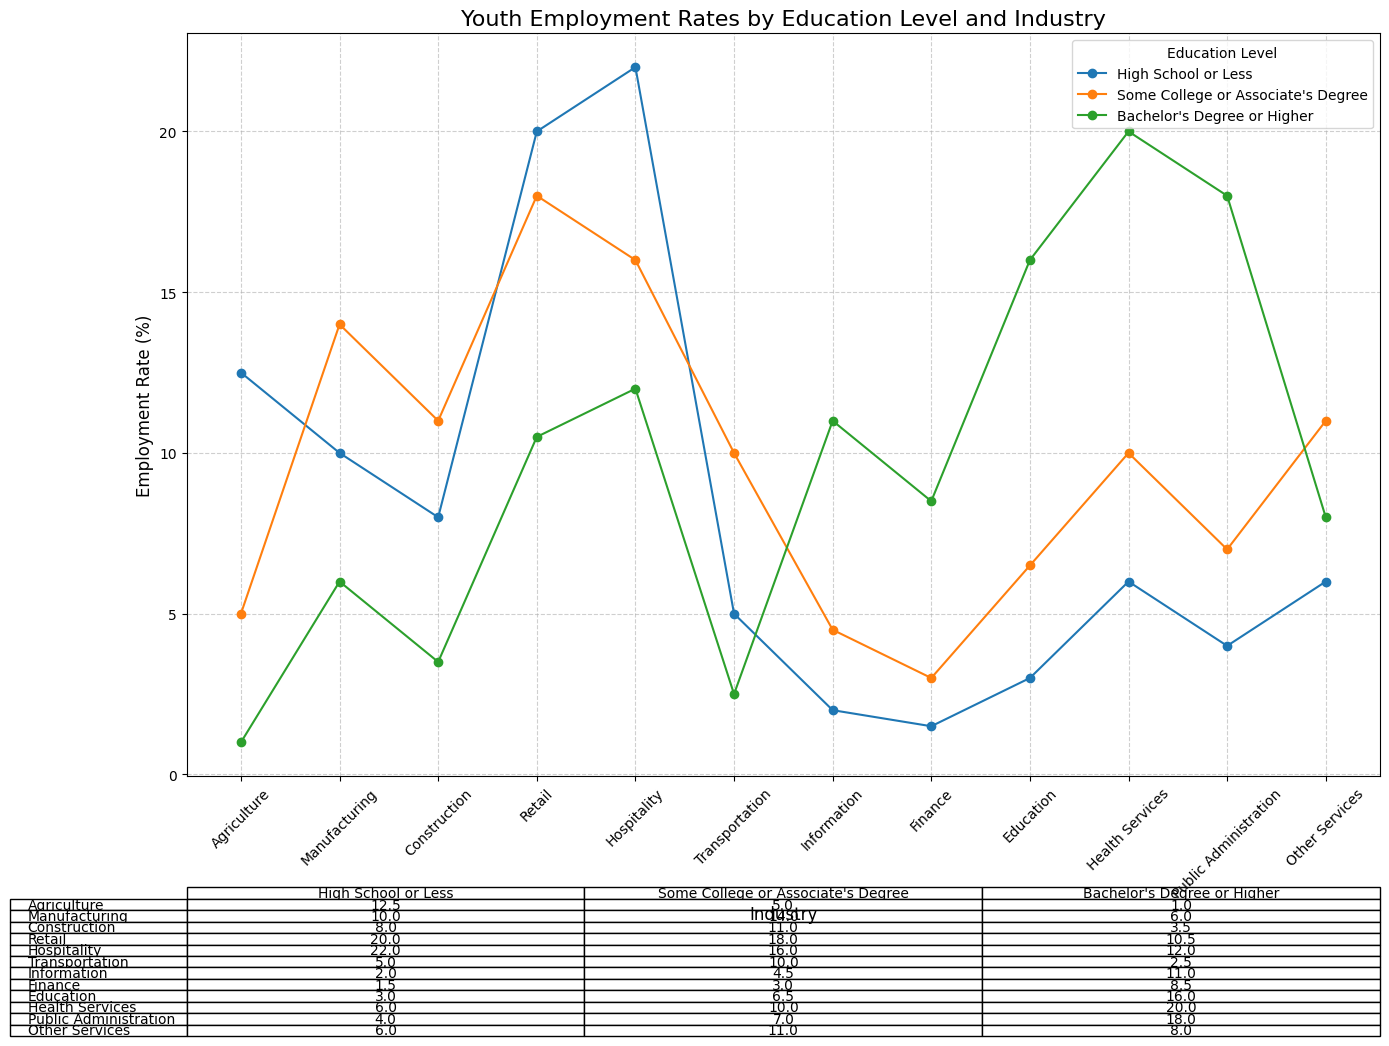Which industry has the highest employment rate for youth with a high school or less education level? Look at the plot and identify the industry with the highest marker for the "High School or Less" education level.
Answer: Hospitality What is the difference in employment rates for youth with some college or an associate's degree between the manufacturing and retail industries? Check the plot for the markers corresponding to "Some College or Associate's Degree" in the manufacturing industry (14.0%) and retail industry (18.0%). Calculate the difference: 18.0% - 14.0% = 4.0%.
Answer: 4.0% Compare the employment rates in the health services industry between youth with a high school or less and a bachelor's degree or higher education level. Which is higher? Look at the plot to find the employment rates in the health services industry for "High School or Less" (6.0%) and "Bachelor's Degree or Higher" (20.0%). The latter is higher.
Answer: Bachelor's Degree or Higher Which education level shows the most varied employment rates across different industries? Visually inspect the plot to see which education level has the most widely spread markers across industries.
Answer: High School or Less What is the total employment rate for youth in the transportation industry across all education levels? Summarize the employment rates for the transportation industry from the plot: 5.0% (High School or Less) + 10.0% (Some College or Associate's Degree) + 2.5% (Bachelor's Degree or Higher). Total: 5.0% + 10.0% + 2.5% = 17.5%.
Answer: 17.5% In which industry do youth with a bachelor's degree or higher have the second-highest employment rate? Find all employment rates for "Bachelor's Degree or Higher" and identify the second-highest. Health Services is the highest (20.0%) and Public Administration is the second-highest (18.0%).
Answer: Public Administration By how much is the employment rate in the finance industry for youth with some college or an associate's degree lower than in the information industry for the same education level? Compare the employment rates for the finance (3.0%) and information (4.5%) industries for "Some College or Associate's Degree." Calculate the difference: 4.5% - 3.0% = 1.5%.
Answer: 1.5% Which industry has an equal employment rate for youth with a high school or less and some college or an associate's degree education level? Look for an industry where the markers for "High School or Less" and "Some College or Associate's Degree" align. Health services show equality (6.0% and 6.0%).
Answer: Health Services 